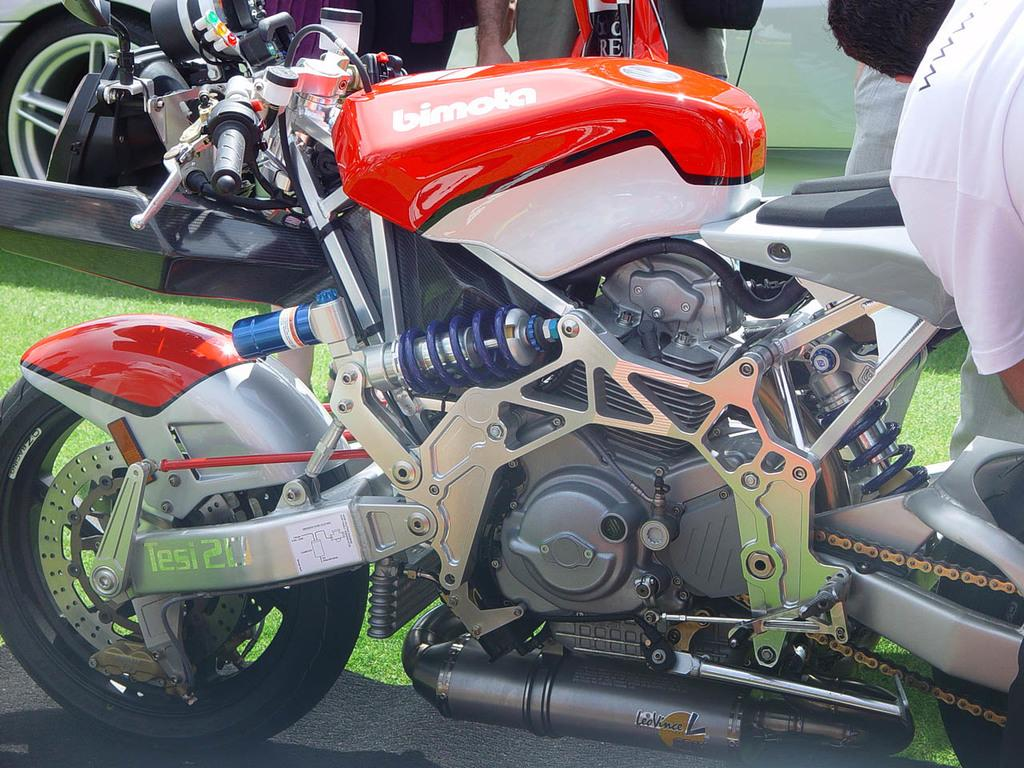What types of objects can be seen in the image? There are vehicles in the image. Are there any living beings present in the image? Yes, there are people in the image. What type of natural environment is visible in the image? There is grass visible in the image. What type of pipe can be seen in the image? There is no pipe present in the image. Is there any smoke visible in the image? There is no smoke visible in the image. 